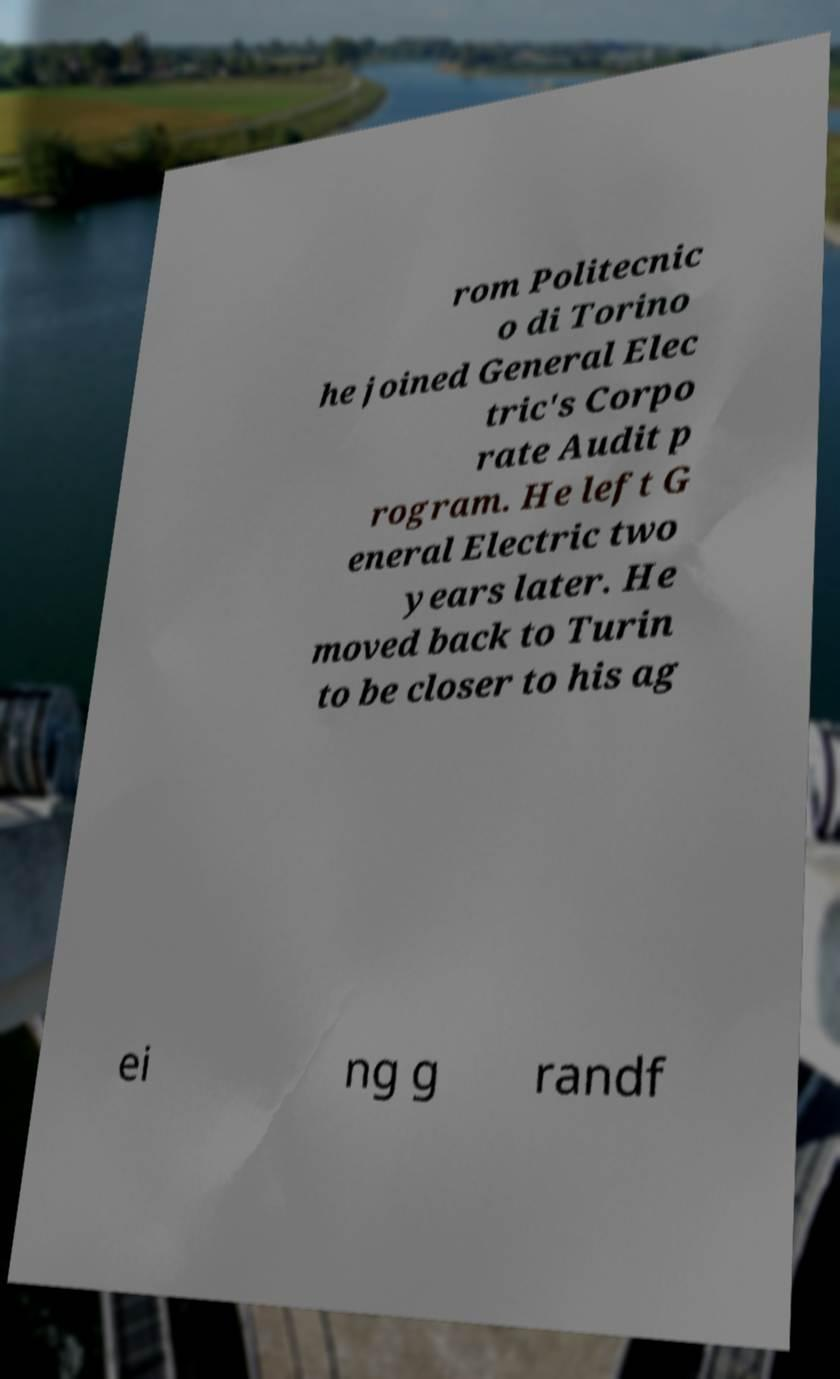Please identify and transcribe the text found in this image. rom Politecnic o di Torino he joined General Elec tric's Corpo rate Audit p rogram. He left G eneral Electric two years later. He moved back to Turin to be closer to his ag ei ng g randf 